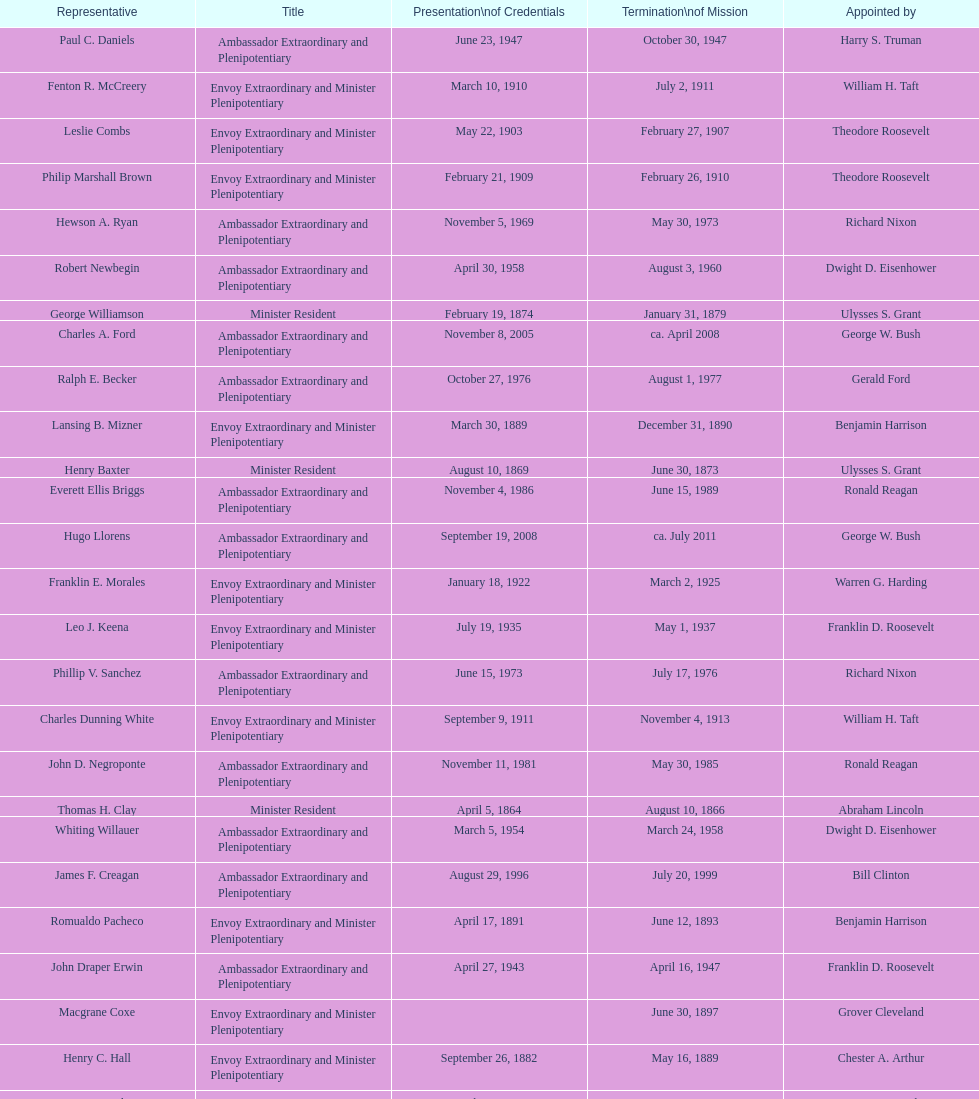What was the length, in years, of leslie combs' term? 4 years. 